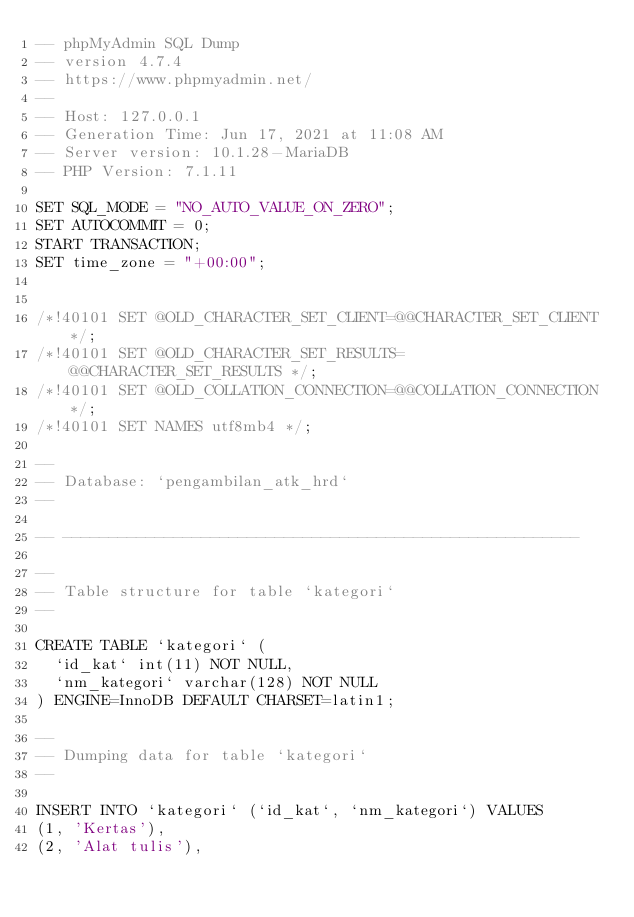<code> <loc_0><loc_0><loc_500><loc_500><_SQL_>-- phpMyAdmin SQL Dump
-- version 4.7.4
-- https://www.phpmyadmin.net/
--
-- Host: 127.0.0.1
-- Generation Time: Jun 17, 2021 at 11:08 AM
-- Server version: 10.1.28-MariaDB
-- PHP Version: 7.1.11

SET SQL_MODE = "NO_AUTO_VALUE_ON_ZERO";
SET AUTOCOMMIT = 0;
START TRANSACTION;
SET time_zone = "+00:00";


/*!40101 SET @OLD_CHARACTER_SET_CLIENT=@@CHARACTER_SET_CLIENT */;
/*!40101 SET @OLD_CHARACTER_SET_RESULTS=@@CHARACTER_SET_RESULTS */;
/*!40101 SET @OLD_COLLATION_CONNECTION=@@COLLATION_CONNECTION */;
/*!40101 SET NAMES utf8mb4 */;

--
-- Database: `pengambilan_atk_hrd`
--

-- --------------------------------------------------------

--
-- Table structure for table `kategori`
--

CREATE TABLE `kategori` (
  `id_kat` int(11) NOT NULL,
  `nm_kategori` varchar(128) NOT NULL
) ENGINE=InnoDB DEFAULT CHARSET=latin1;

--
-- Dumping data for table `kategori`
--

INSERT INTO `kategori` (`id_kat`, `nm_kategori`) VALUES
(1, 'Kertas'),
(2, 'Alat tulis'),</code> 